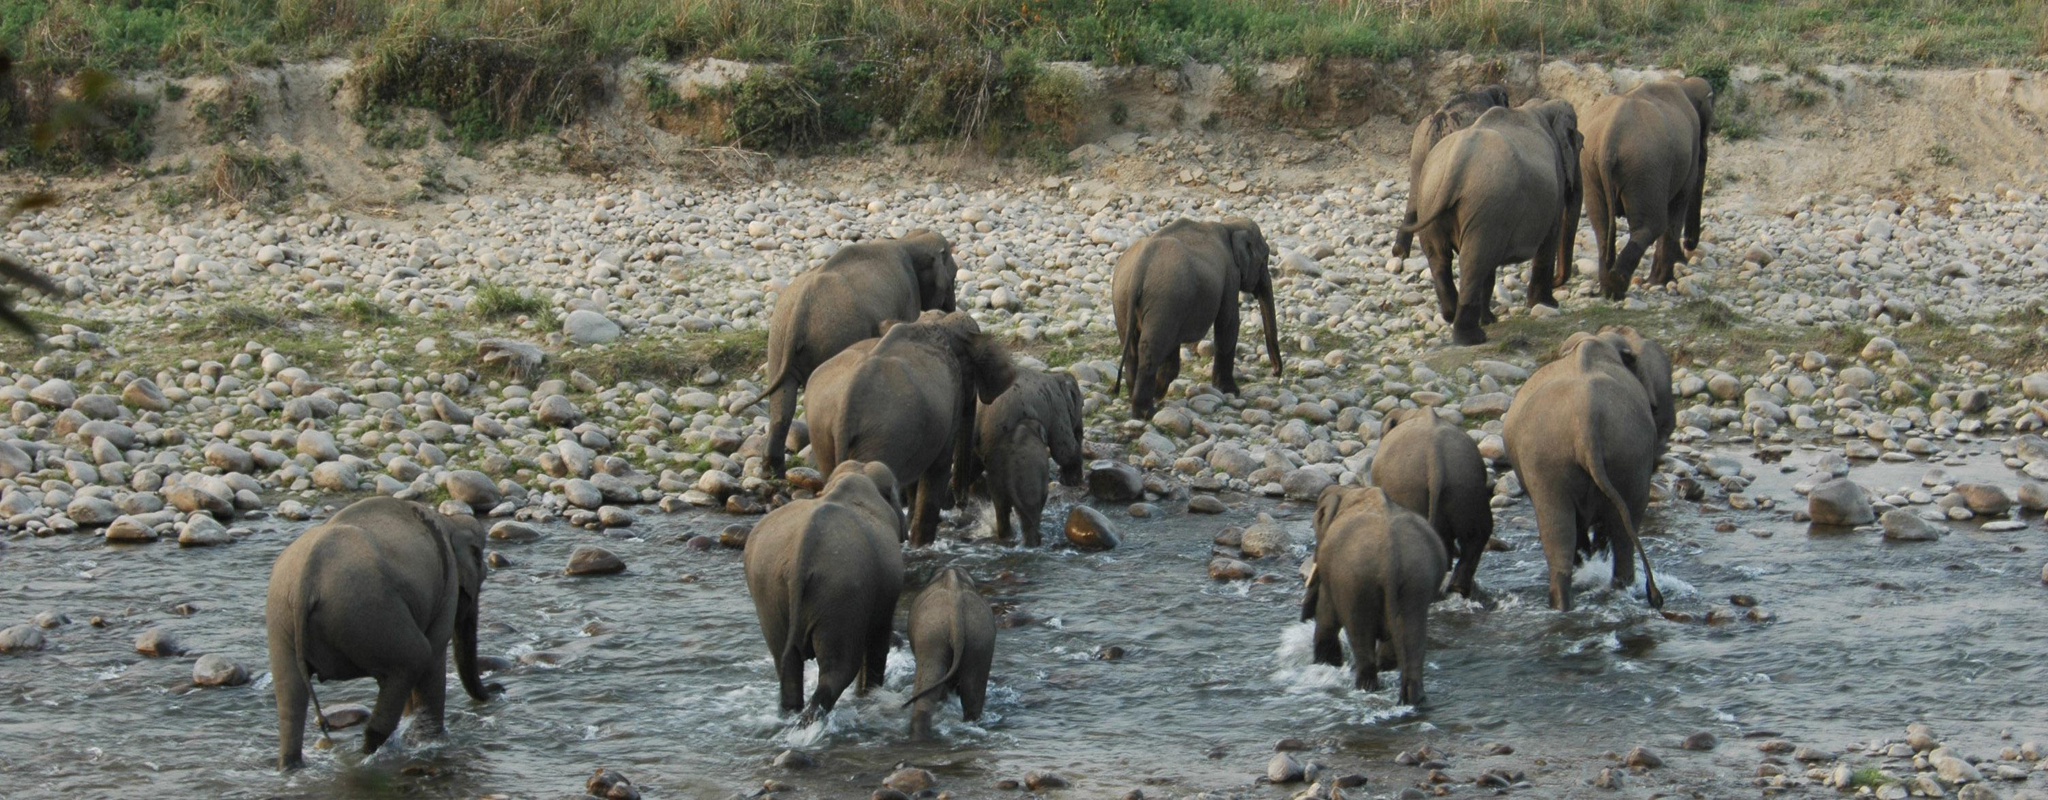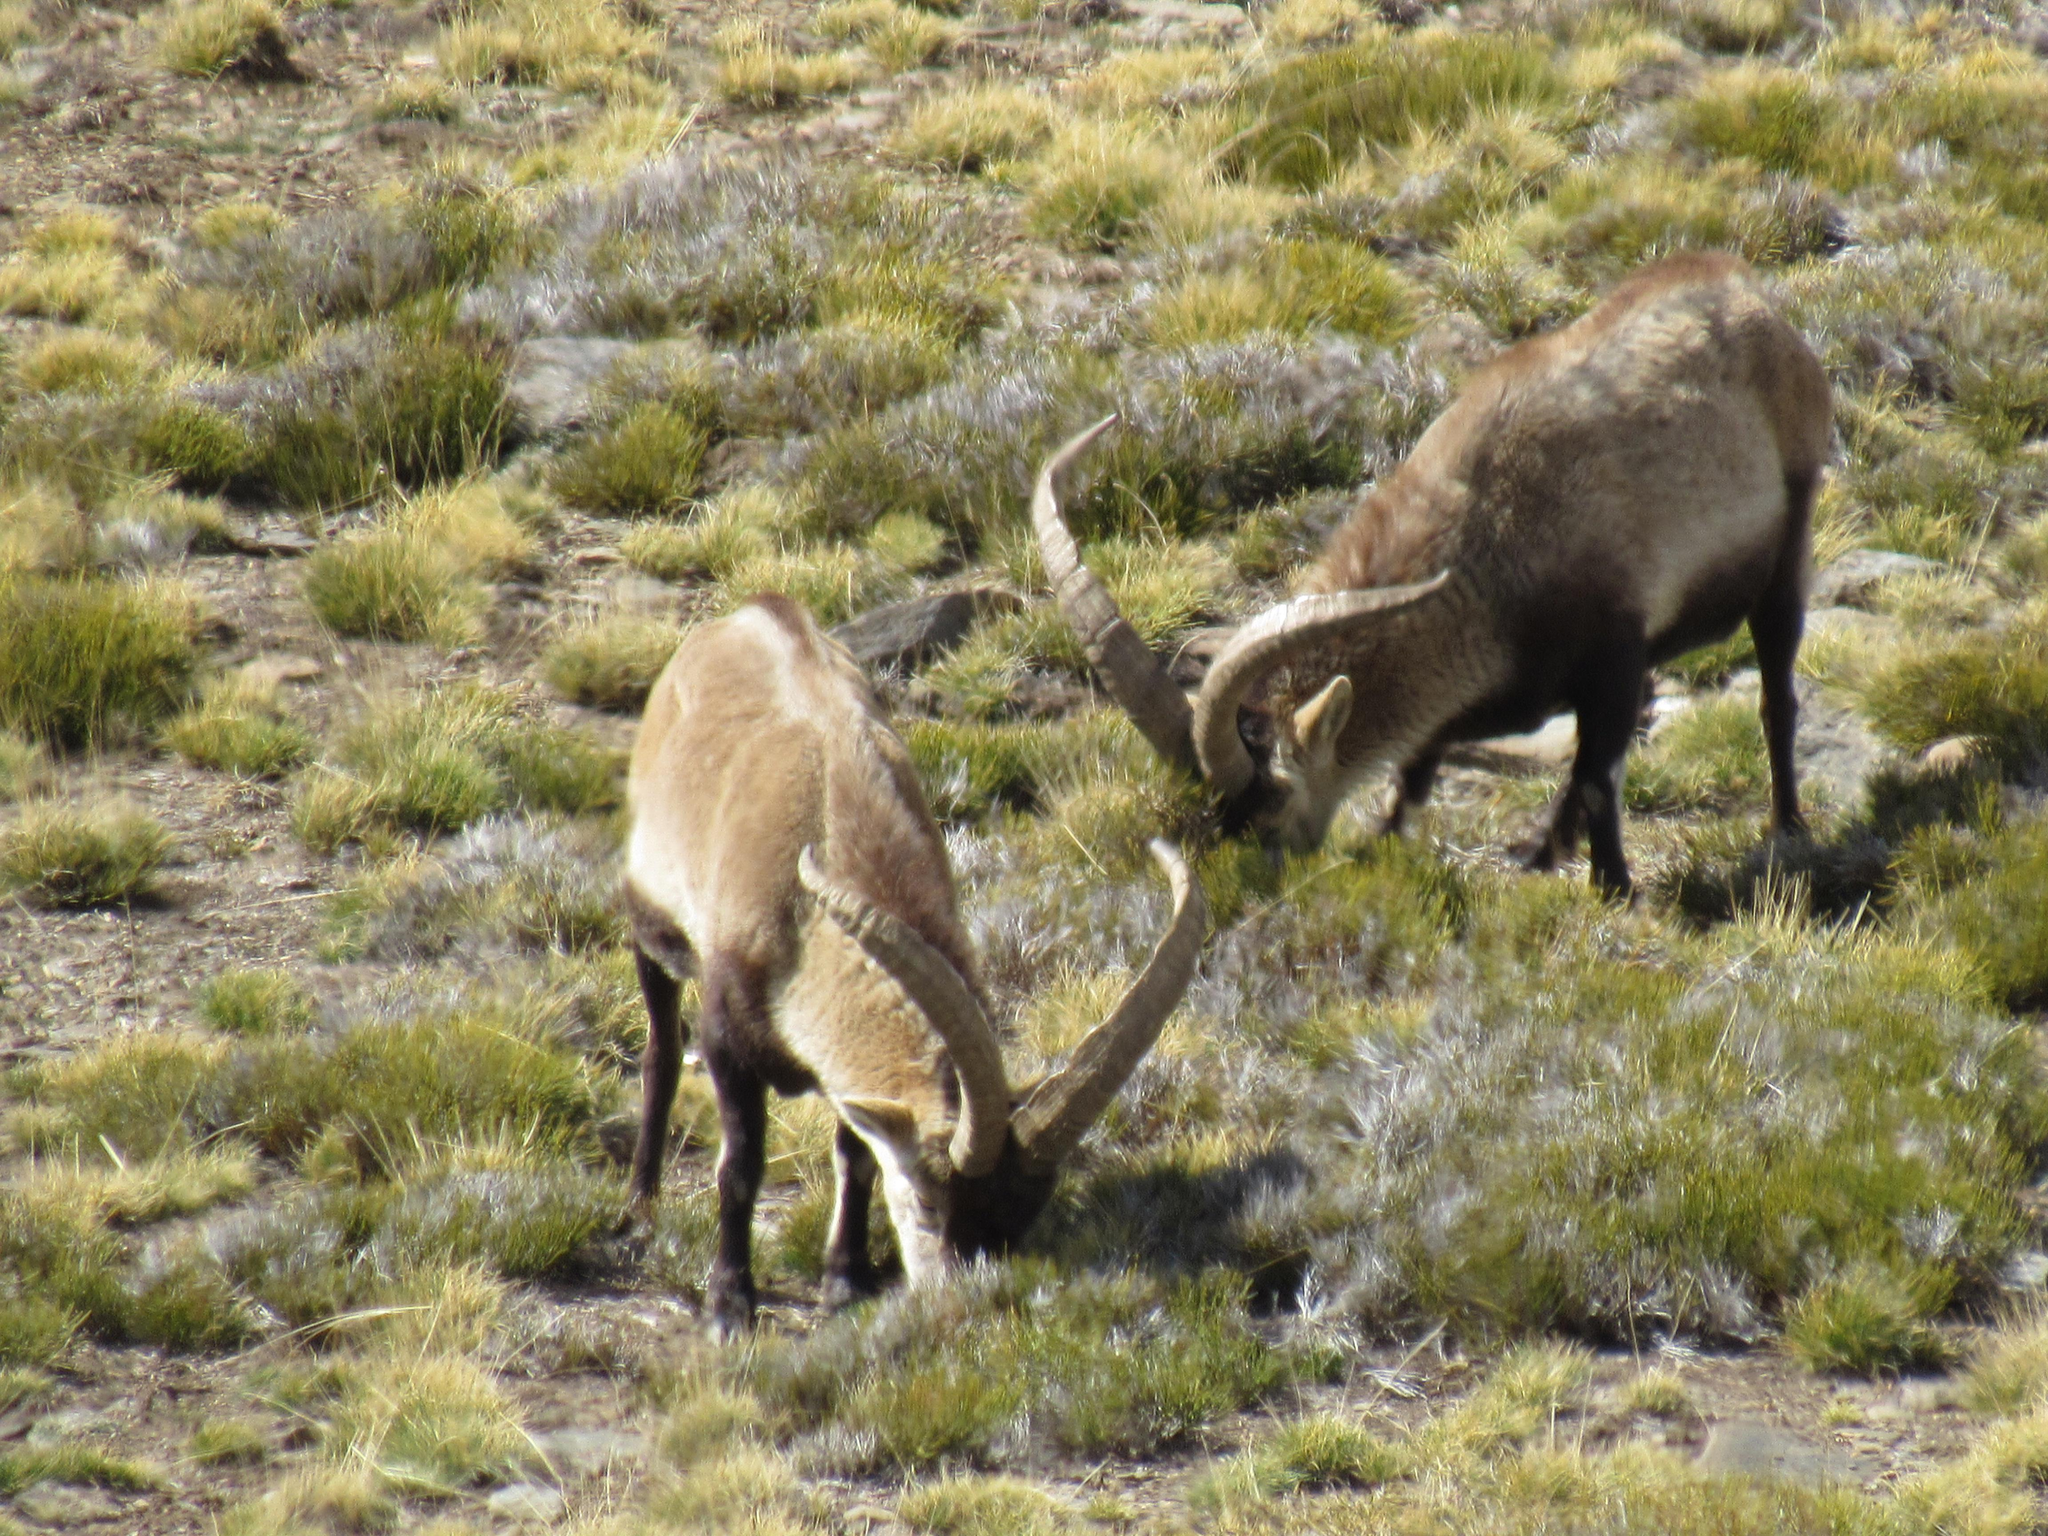The first image is the image on the left, the second image is the image on the right. For the images shown, is this caption "In one of the images all the animals are walking." true? Answer yes or no. Yes. 